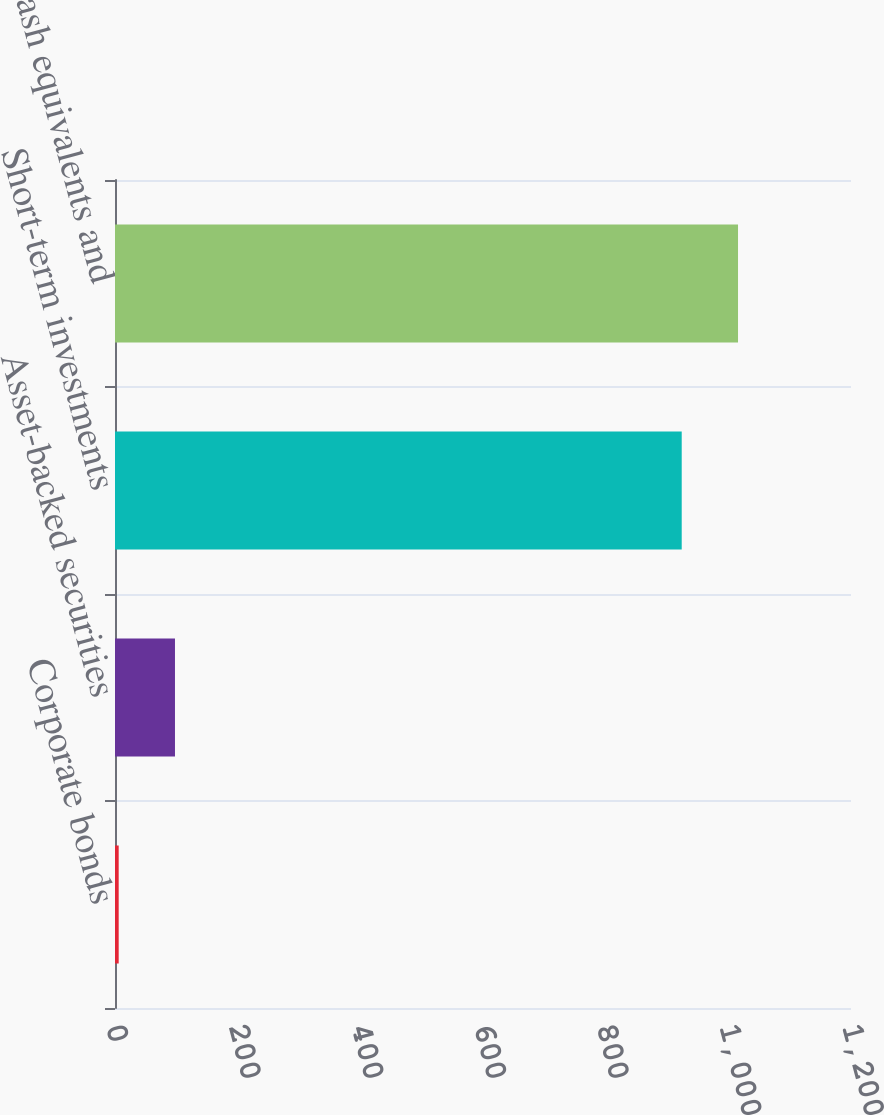<chart> <loc_0><loc_0><loc_500><loc_500><bar_chart><fcel>Corporate bonds<fcel>Asset-backed securities<fcel>Short-term investments<fcel>Cash cash equivalents and<nl><fcel>6<fcel>97.8<fcel>924<fcel>1015.8<nl></chart> 